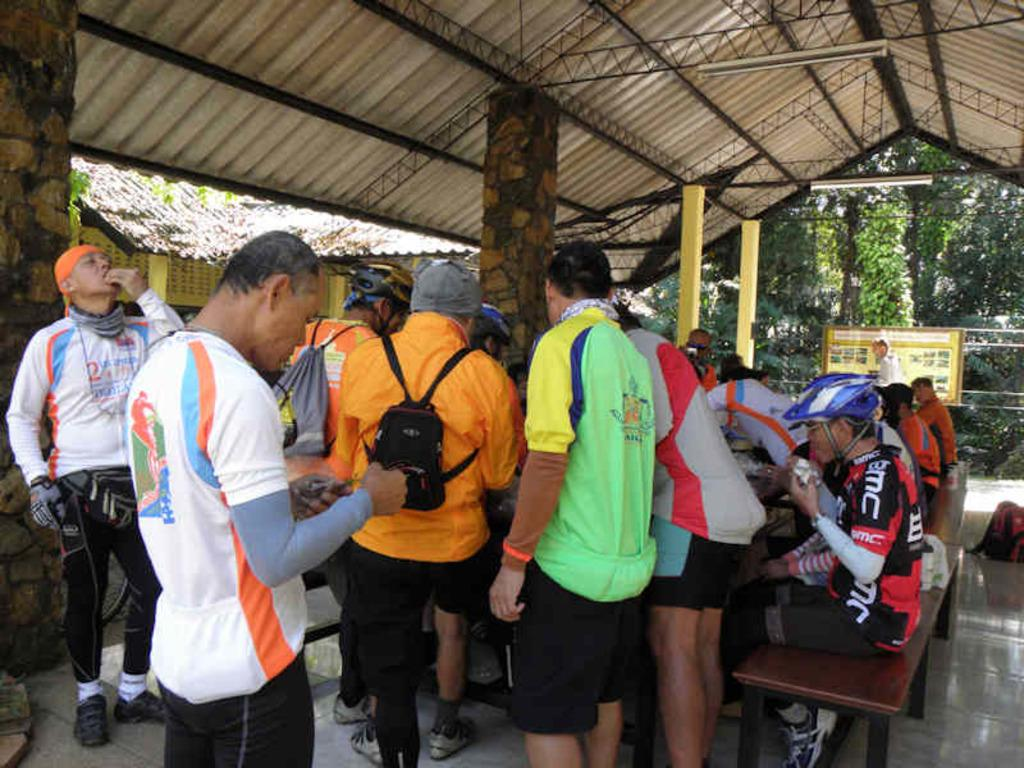How many people are in the image? There are people in the image, but the exact number is not specified. What are some of the people in the image doing? Some people are sitting. What can be observed about the clothing of the people in the image? The people are wearing different colored dresses. Are any accessories visible on the people in the image? Some people are wearing bags. What can be seen in the background of the image? There is a building, a shed, trees, and a board in the background. Can you tell me where the mother is located in the image? There is no mention of a mother in the image, so it is not possible to determine her location. What type of heart is depicted on the board in the background? There is no heart visible on the board in the background; it is not mentioned in the facts. 